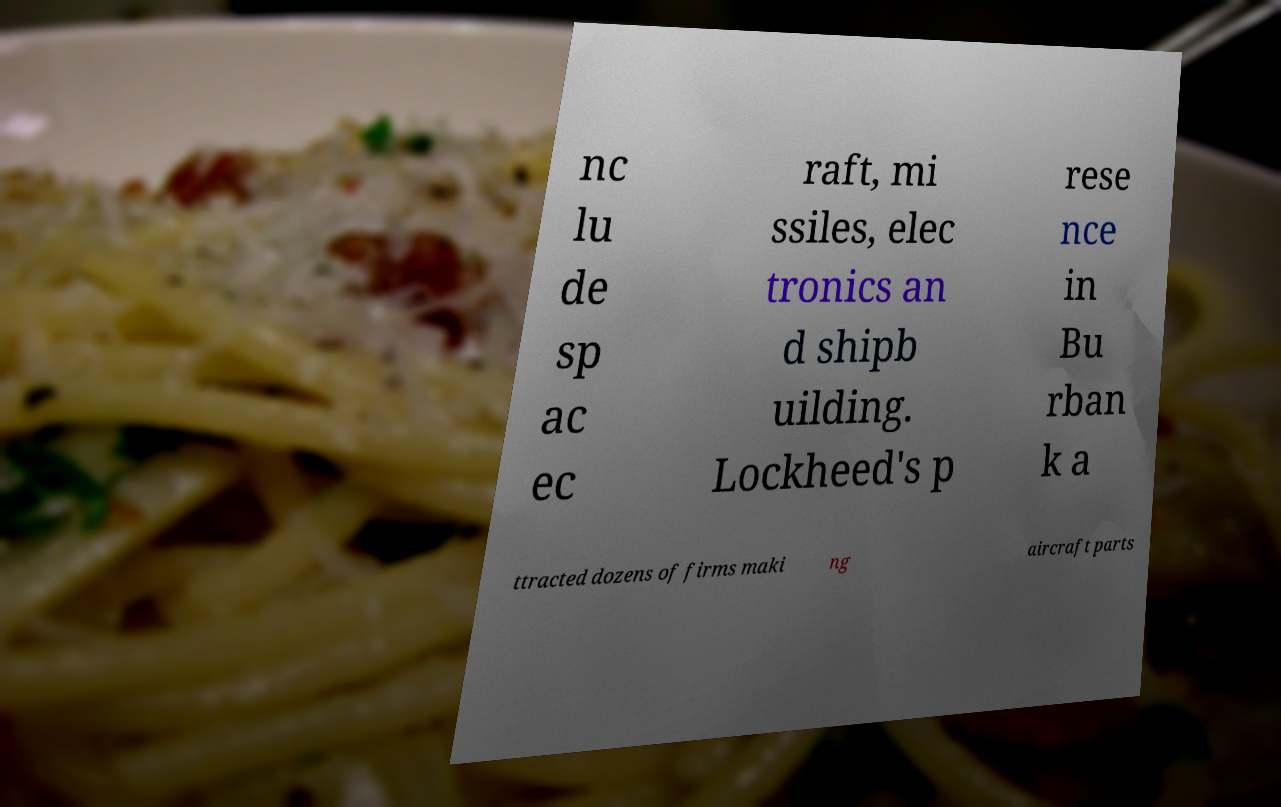Could you assist in decoding the text presented in this image and type it out clearly? nc lu de sp ac ec raft, mi ssiles, elec tronics an d shipb uilding. Lockheed's p rese nce in Bu rban k a ttracted dozens of firms maki ng aircraft parts 